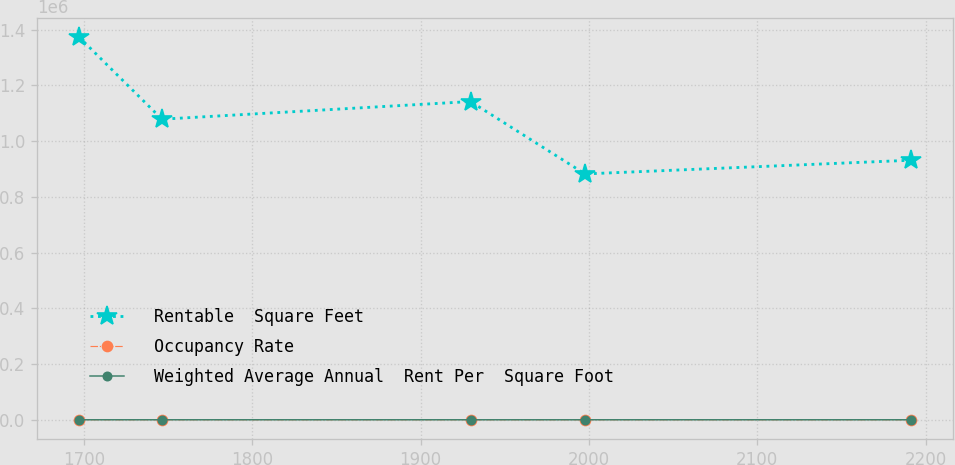Convert chart to OTSL. <chart><loc_0><loc_0><loc_500><loc_500><line_chart><ecel><fcel>Rentable  Square Feet<fcel>Occupancy Rate<fcel>Weighted Average Annual  Rent Per  Square Foot<nl><fcel>1696.89<fcel>1.37479e+06<fcel>81.81<fcel>26.04<nl><fcel>1746.36<fcel>1.07884e+06<fcel>97.22<fcel>20.12<nl><fcel>1929.68<fcel>1.14221e+06<fcel>95.39<fcel>19.38<nl><fcel>1997.69<fcel>882382<fcel>77.86<fcel>18.64<nl><fcel>2191.57<fcel>931622<fcel>79.69<fcel>21.07<nl></chart> 